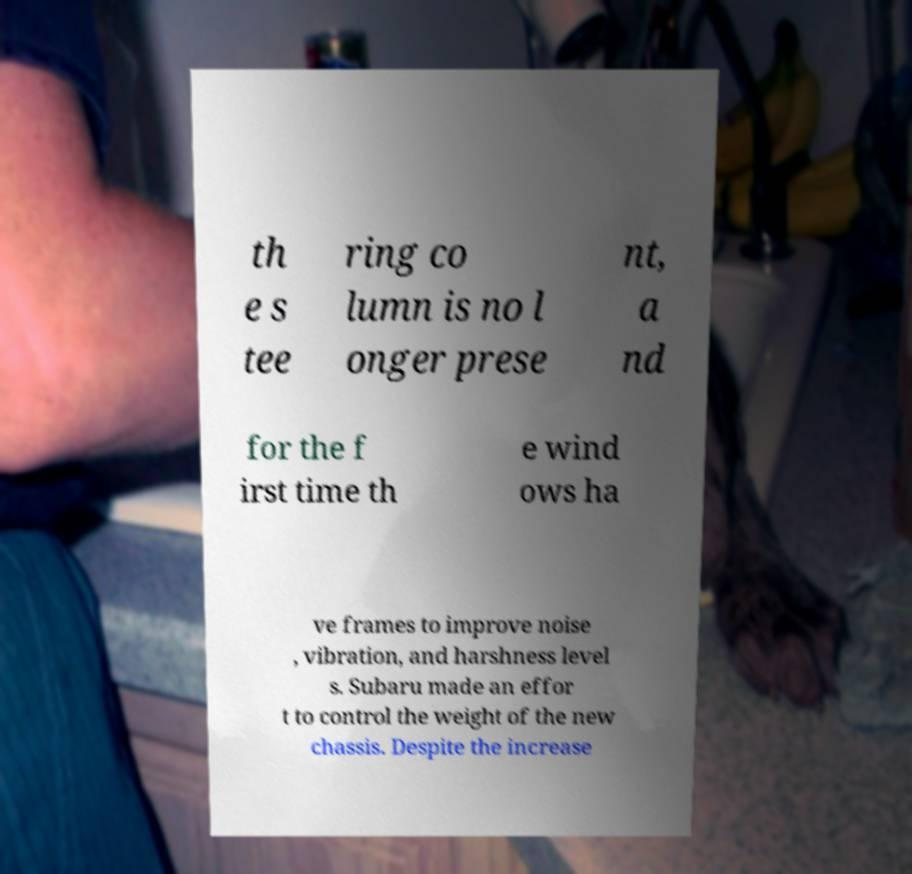For documentation purposes, I need the text within this image transcribed. Could you provide that? th e s tee ring co lumn is no l onger prese nt, a nd for the f irst time th e wind ows ha ve frames to improve noise , vibration, and harshness level s. Subaru made an effor t to control the weight of the new chassis. Despite the increase 